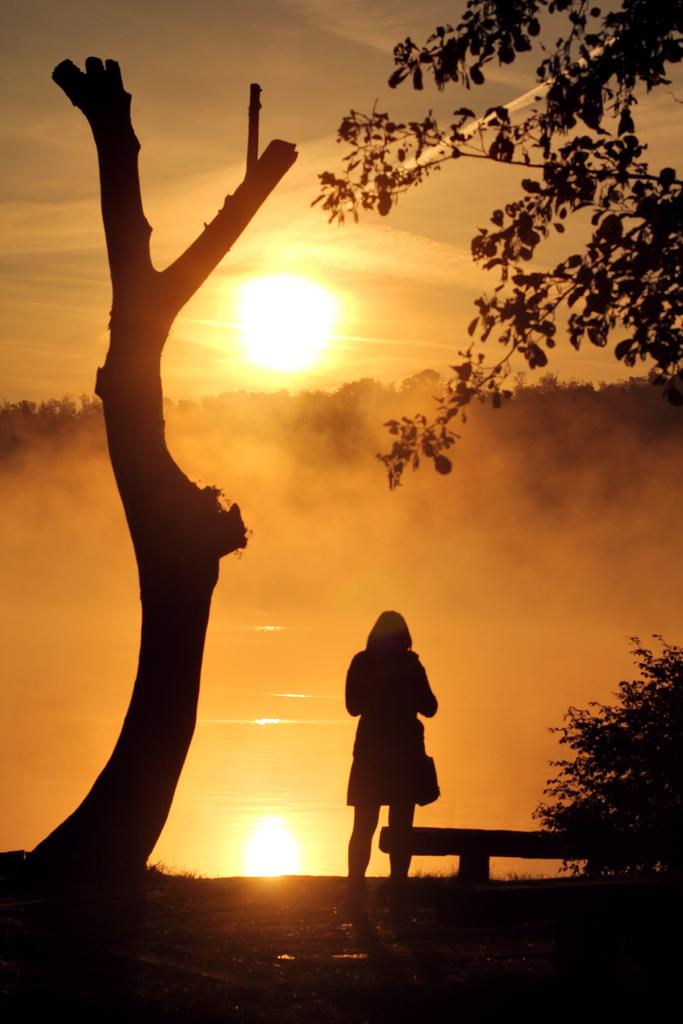What is the main subject in the middle of the image? There is a woman standing in the middle of the image. What type of vegetation is on the right side of the image? There are trees on the right side of the image. What celestial body is visible in the middle of the image? The sun is visible in the middle of the image. What is present at the bottom of the image? There is water at the bottom of the image. What note is the woman writing in the image? There is no note or writing activity present in the image. Can you see the writer's hand in the image? There is no writer or hand visible in the image; it features a woman standing in front of trees, with the sun and water in the background. 